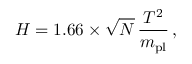<formula> <loc_0><loc_0><loc_500><loc_500>H = 1 . 6 6 \times \sqrt { N } \, \frac { T ^ { 2 } } { m _ { p l } } \, ,</formula> 